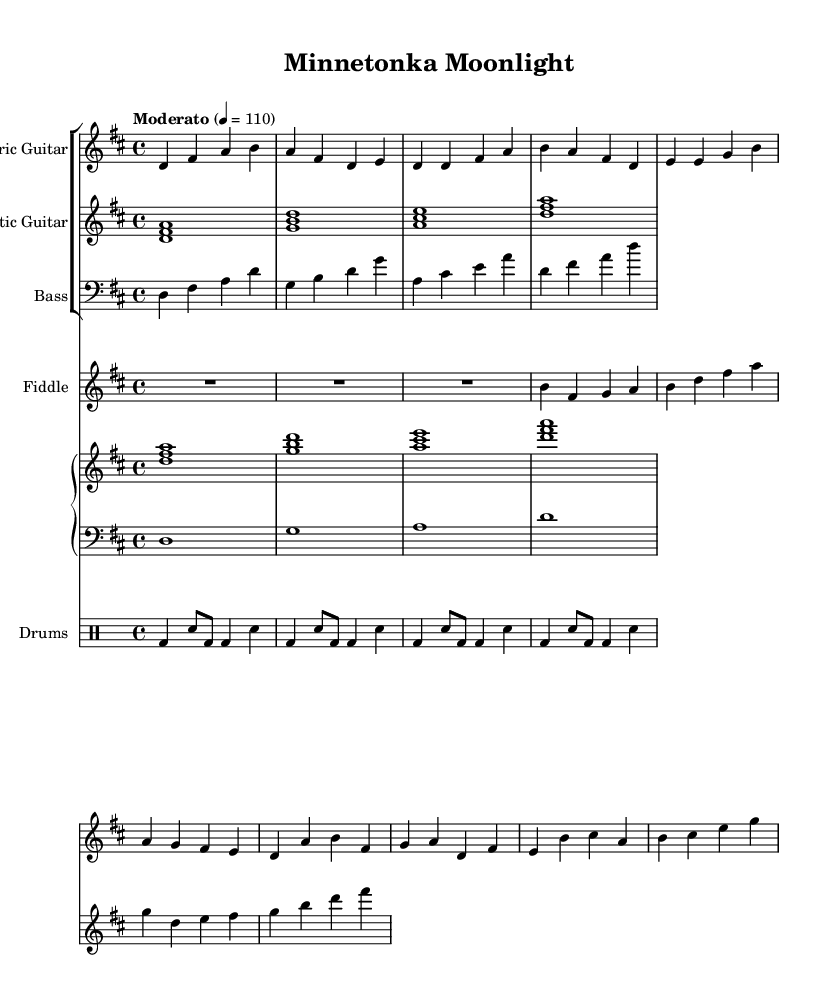What is the key signature of this music? The key signature indicated at the beginning of the sheet music is D major, which has two sharps (F# and C#).
Answer: D major What is the time signature of this piece? The time signature shown at the start is 4/4, which means there are four beats in each measure and the quarter note gets one beat.
Answer: 4/4 What is the tempo marking for this piece? The tempo indicated in the header states "Moderato" with a beat of quarter note equals 110, suggesting a moderate speed.
Answer: Moderato 4 = 110 How many instruments are featured in this score? By counting the distinct staves, there are five instruments: electric guitar, acoustic guitar, bass, fiddle, and drums.
Answer: Five Which instrument plays the highest range of notes? Looking at the notated pitches, the electric guitar consistently plays higher notes than the other instruments, including the fiddle.
Answer: Electric guitar What style of music does this piece represent? The combination of jazz-rock elements, along with the use of folk instruments like the fiddle, suggests it falls into the fusion genre.
Answer: Fusion What rhythmic element is predominantly used in the drums? The drum part primarily utilizes bass drum and snare hits in a steady pattern, characteristic of rock and jazz fusion.
Answer: Bass drum and snare 